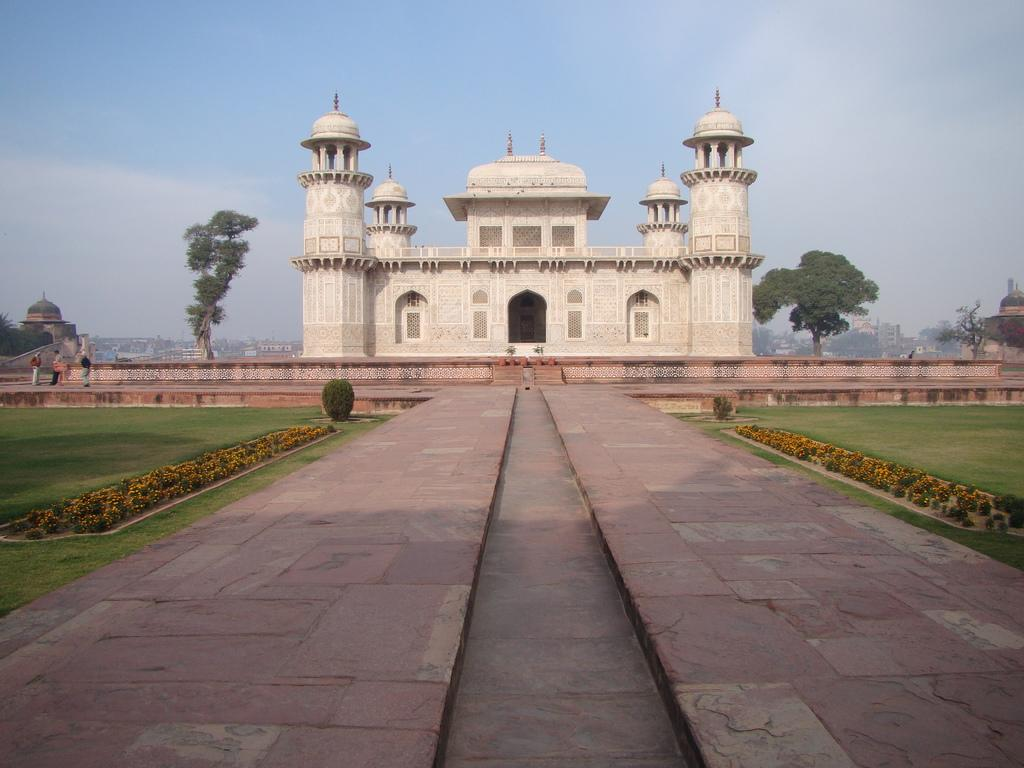What type of structures can be seen in the image? There are buildings in the image. What type of vegetation is present in the image? There are trees and plants in the image. Are there any living beings in the image? Yes, there are people standing in the image. What is the ground covered with in the image? The ground is covered with grass in the image. How would you describe the sky in the image? The sky is blue and cloudy in the image. What type of milk is being served at the governor's event in the image? There is no mention of milk, a governor, or an event in the image. The image features buildings, trees, plants, people, grass, and a blue and cloudy sky. 